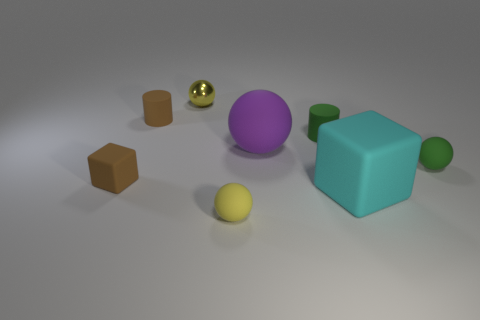Subtract all large purple matte balls. How many balls are left? 3 Add 1 large purple cylinders. How many objects exist? 9 Subtract all gray spheres. Subtract all gray cubes. How many spheres are left? 4 Subtract all cylinders. How many objects are left? 6 Add 1 brown cylinders. How many brown cylinders are left? 2 Add 2 yellow shiny spheres. How many yellow shiny spheres exist? 3 Subtract 1 brown cubes. How many objects are left? 7 Subtract all metal cylinders. Subtract all matte balls. How many objects are left? 5 